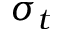<formula> <loc_0><loc_0><loc_500><loc_500>\sigma _ { t }</formula> 